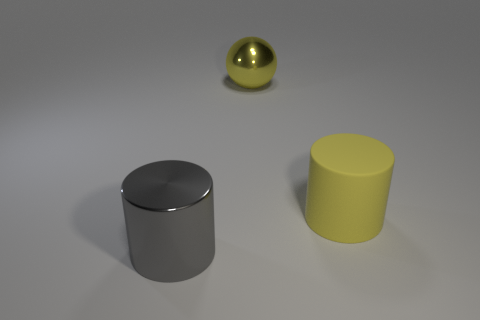Add 2 brown spheres. How many objects exist? 5 Subtract all spheres. How many objects are left? 2 Subtract 0 brown spheres. How many objects are left? 3 Subtract all tiny gray balls. Subtract all large metallic things. How many objects are left? 1 Add 2 yellow spheres. How many yellow spheres are left? 3 Add 2 red rubber balls. How many red rubber balls exist? 2 